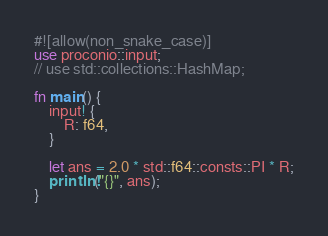<code> <loc_0><loc_0><loc_500><loc_500><_Rust_>#![allow(non_snake_case)]
use proconio::input;
// use std::collections::HashMap;

fn main() {
    input! {
        R: f64,
    }

    let ans = 2.0 * std::f64::consts::PI * R;
    println!("{}", ans);
}
</code> 